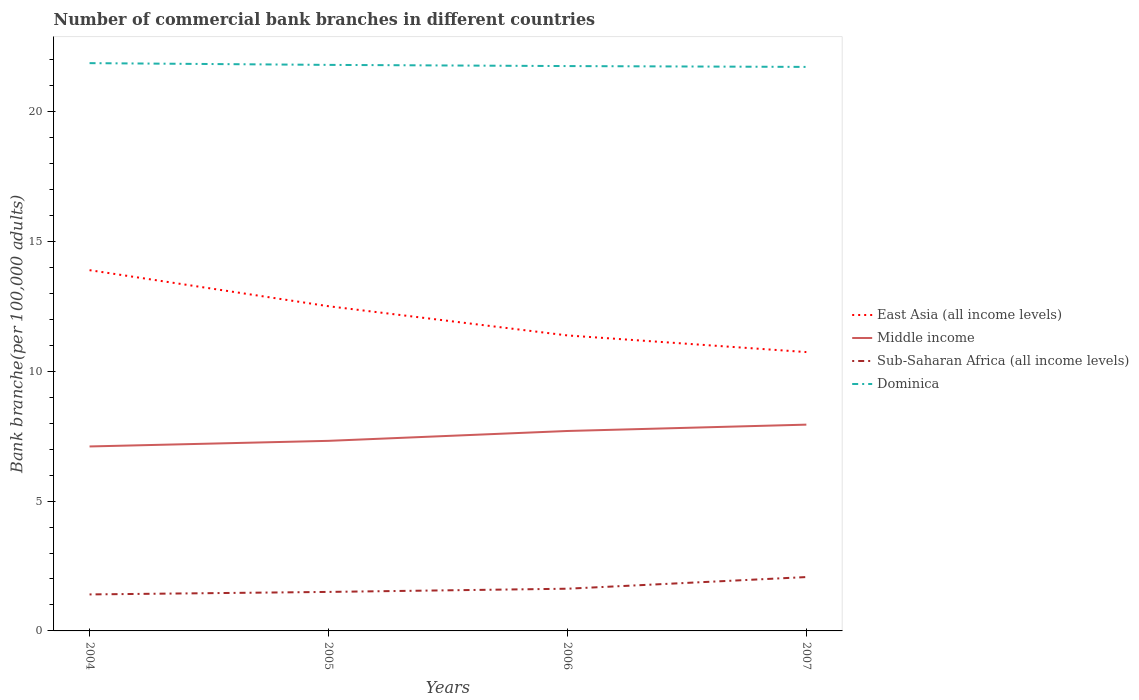How many different coloured lines are there?
Ensure brevity in your answer.  4. Does the line corresponding to Sub-Saharan Africa (all income levels) intersect with the line corresponding to Middle income?
Your answer should be very brief. No. Across all years, what is the maximum number of commercial bank branches in Dominica?
Your answer should be compact. 21.72. What is the total number of commercial bank branches in Sub-Saharan Africa (all income levels) in the graph?
Give a very brief answer. -0.1. What is the difference between the highest and the second highest number of commercial bank branches in Dominica?
Your answer should be very brief. 0.15. How many lines are there?
Your response must be concise. 4. How many years are there in the graph?
Make the answer very short. 4. What is the difference between two consecutive major ticks on the Y-axis?
Make the answer very short. 5. Does the graph contain any zero values?
Offer a very short reply. No. Where does the legend appear in the graph?
Your response must be concise. Center right. How are the legend labels stacked?
Offer a terse response. Vertical. What is the title of the graph?
Make the answer very short. Number of commercial bank branches in different countries. What is the label or title of the Y-axis?
Offer a very short reply. Bank branche(per 100,0 adults). What is the Bank branche(per 100,000 adults) in East Asia (all income levels) in 2004?
Ensure brevity in your answer.  13.89. What is the Bank branche(per 100,000 adults) in Middle income in 2004?
Provide a short and direct response. 7.1. What is the Bank branche(per 100,000 adults) in Sub-Saharan Africa (all income levels) in 2004?
Your response must be concise. 1.41. What is the Bank branche(per 100,000 adults) in Dominica in 2004?
Provide a succinct answer. 21.86. What is the Bank branche(per 100,000 adults) of East Asia (all income levels) in 2005?
Your answer should be very brief. 12.5. What is the Bank branche(per 100,000 adults) of Middle income in 2005?
Your response must be concise. 7.32. What is the Bank branche(per 100,000 adults) of Sub-Saharan Africa (all income levels) in 2005?
Provide a short and direct response. 1.5. What is the Bank branche(per 100,000 adults) in Dominica in 2005?
Your answer should be compact. 21.8. What is the Bank branche(per 100,000 adults) in East Asia (all income levels) in 2006?
Keep it short and to the point. 11.38. What is the Bank branche(per 100,000 adults) in Middle income in 2006?
Your response must be concise. 7.7. What is the Bank branche(per 100,000 adults) of Sub-Saharan Africa (all income levels) in 2006?
Offer a terse response. 1.63. What is the Bank branche(per 100,000 adults) of Dominica in 2006?
Your response must be concise. 21.75. What is the Bank branche(per 100,000 adults) in East Asia (all income levels) in 2007?
Your answer should be compact. 10.74. What is the Bank branche(per 100,000 adults) of Middle income in 2007?
Provide a short and direct response. 7.94. What is the Bank branche(per 100,000 adults) in Sub-Saharan Africa (all income levels) in 2007?
Your response must be concise. 2.07. What is the Bank branche(per 100,000 adults) of Dominica in 2007?
Give a very brief answer. 21.72. Across all years, what is the maximum Bank branche(per 100,000 adults) of East Asia (all income levels)?
Keep it short and to the point. 13.89. Across all years, what is the maximum Bank branche(per 100,000 adults) in Middle income?
Provide a succinct answer. 7.94. Across all years, what is the maximum Bank branche(per 100,000 adults) of Sub-Saharan Africa (all income levels)?
Keep it short and to the point. 2.07. Across all years, what is the maximum Bank branche(per 100,000 adults) in Dominica?
Your answer should be compact. 21.86. Across all years, what is the minimum Bank branche(per 100,000 adults) of East Asia (all income levels)?
Your answer should be very brief. 10.74. Across all years, what is the minimum Bank branche(per 100,000 adults) in Middle income?
Provide a short and direct response. 7.1. Across all years, what is the minimum Bank branche(per 100,000 adults) of Sub-Saharan Africa (all income levels)?
Offer a very short reply. 1.41. Across all years, what is the minimum Bank branche(per 100,000 adults) in Dominica?
Keep it short and to the point. 21.72. What is the total Bank branche(per 100,000 adults) in East Asia (all income levels) in the graph?
Make the answer very short. 48.51. What is the total Bank branche(per 100,000 adults) in Middle income in the graph?
Offer a terse response. 30.06. What is the total Bank branche(per 100,000 adults) in Sub-Saharan Africa (all income levels) in the graph?
Your response must be concise. 6.61. What is the total Bank branche(per 100,000 adults) of Dominica in the graph?
Provide a succinct answer. 87.12. What is the difference between the Bank branche(per 100,000 adults) of East Asia (all income levels) in 2004 and that in 2005?
Your response must be concise. 1.39. What is the difference between the Bank branche(per 100,000 adults) in Middle income in 2004 and that in 2005?
Your answer should be very brief. -0.22. What is the difference between the Bank branche(per 100,000 adults) in Sub-Saharan Africa (all income levels) in 2004 and that in 2005?
Offer a terse response. -0.1. What is the difference between the Bank branche(per 100,000 adults) in Dominica in 2004 and that in 2005?
Provide a succinct answer. 0.07. What is the difference between the Bank branche(per 100,000 adults) in East Asia (all income levels) in 2004 and that in 2006?
Your answer should be compact. 2.51. What is the difference between the Bank branche(per 100,000 adults) of Middle income in 2004 and that in 2006?
Keep it short and to the point. -0.6. What is the difference between the Bank branche(per 100,000 adults) of Sub-Saharan Africa (all income levels) in 2004 and that in 2006?
Your response must be concise. -0.22. What is the difference between the Bank branche(per 100,000 adults) in Dominica in 2004 and that in 2006?
Your answer should be compact. 0.11. What is the difference between the Bank branche(per 100,000 adults) of East Asia (all income levels) in 2004 and that in 2007?
Offer a terse response. 3.15. What is the difference between the Bank branche(per 100,000 adults) in Middle income in 2004 and that in 2007?
Offer a very short reply. -0.84. What is the difference between the Bank branche(per 100,000 adults) in Sub-Saharan Africa (all income levels) in 2004 and that in 2007?
Offer a terse response. -0.67. What is the difference between the Bank branche(per 100,000 adults) in Dominica in 2004 and that in 2007?
Ensure brevity in your answer.  0.15. What is the difference between the Bank branche(per 100,000 adults) in East Asia (all income levels) in 2005 and that in 2006?
Your answer should be very brief. 1.12. What is the difference between the Bank branche(per 100,000 adults) of Middle income in 2005 and that in 2006?
Your answer should be very brief. -0.38. What is the difference between the Bank branche(per 100,000 adults) of Sub-Saharan Africa (all income levels) in 2005 and that in 2006?
Your answer should be very brief. -0.12. What is the difference between the Bank branche(per 100,000 adults) in Dominica in 2005 and that in 2006?
Your answer should be very brief. 0.05. What is the difference between the Bank branche(per 100,000 adults) in East Asia (all income levels) in 2005 and that in 2007?
Provide a succinct answer. 1.77. What is the difference between the Bank branche(per 100,000 adults) of Middle income in 2005 and that in 2007?
Offer a very short reply. -0.62. What is the difference between the Bank branche(per 100,000 adults) of Sub-Saharan Africa (all income levels) in 2005 and that in 2007?
Make the answer very short. -0.57. What is the difference between the Bank branche(per 100,000 adults) in Dominica in 2005 and that in 2007?
Offer a very short reply. 0.08. What is the difference between the Bank branche(per 100,000 adults) of East Asia (all income levels) in 2006 and that in 2007?
Your answer should be compact. 0.64. What is the difference between the Bank branche(per 100,000 adults) of Middle income in 2006 and that in 2007?
Make the answer very short. -0.24. What is the difference between the Bank branche(per 100,000 adults) in Sub-Saharan Africa (all income levels) in 2006 and that in 2007?
Provide a short and direct response. -0.45. What is the difference between the Bank branche(per 100,000 adults) of Dominica in 2006 and that in 2007?
Provide a short and direct response. 0.03. What is the difference between the Bank branche(per 100,000 adults) in East Asia (all income levels) in 2004 and the Bank branche(per 100,000 adults) in Middle income in 2005?
Provide a succinct answer. 6.57. What is the difference between the Bank branche(per 100,000 adults) of East Asia (all income levels) in 2004 and the Bank branche(per 100,000 adults) of Sub-Saharan Africa (all income levels) in 2005?
Keep it short and to the point. 12.39. What is the difference between the Bank branche(per 100,000 adults) in East Asia (all income levels) in 2004 and the Bank branche(per 100,000 adults) in Dominica in 2005?
Keep it short and to the point. -7.9. What is the difference between the Bank branche(per 100,000 adults) of Middle income in 2004 and the Bank branche(per 100,000 adults) of Sub-Saharan Africa (all income levels) in 2005?
Your answer should be compact. 5.6. What is the difference between the Bank branche(per 100,000 adults) of Middle income in 2004 and the Bank branche(per 100,000 adults) of Dominica in 2005?
Provide a short and direct response. -14.69. What is the difference between the Bank branche(per 100,000 adults) in Sub-Saharan Africa (all income levels) in 2004 and the Bank branche(per 100,000 adults) in Dominica in 2005?
Your answer should be very brief. -20.39. What is the difference between the Bank branche(per 100,000 adults) in East Asia (all income levels) in 2004 and the Bank branche(per 100,000 adults) in Middle income in 2006?
Provide a short and direct response. 6.19. What is the difference between the Bank branche(per 100,000 adults) of East Asia (all income levels) in 2004 and the Bank branche(per 100,000 adults) of Sub-Saharan Africa (all income levels) in 2006?
Your response must be concise. 12.27. What is the difference between the Bank branche(per 100,000 adults) in East Asia (all income levels) in 2004 and the Bank branche(per 100,000 adults) in Dominica in 2006?
Ensure brevity in your answer.  -7.86. What is the difference between the Bank branche(per 100,000 adults) in Middle income in 2004 and the Bank branche(per 100,000 adults) in Sub-Saharan Africa (all income levels) in 2006?
Keep it short and to the point. 5.48. What is the difference between the Bank branche(per 100,000 adults) of Middle income in 2004 and the Bank branche(per 100,000 adults) of Dominica in 2006?
Your answer should be very brief. -14.65. What is the difference between the Bank branche(per 100,000 adults) in Sub-Saharan Africa (all income levels) in 2004 and the Bank branche(per 100,000 adults) in Dominica in 2006?
Keep it short and to the point. -20.34. What is the difference between the Bank branche(per 100,000 adults) in East Asia (all income levels) in 2004 and the Bank branche(per 100,000 adults) in Middle income in 2007?
Ensure brevity in your answer.  5.95. What is the difference between the Bank branche(per 100,000 adults) of East Asia (all income levels) in 2004 and the Bank branche(per 100,000 adults) of Sub-Saharan Africa (all income levels) in 2007?
Your answer should be compact. 11.82. What is the difference between the Bank branche(per 100,000 adults) of East Asia (all income levels) in 2004 and the Bank branche(per 100,000 adults) of Dominica in 2007?
Make the answer very short. -7.83. What is the difference between the Bank branche(per 100,000 adults) in Middle income in 2004 and the Bank branche(per 100,000 adults) in Sub-Saharan Africa (all income levels) in 2007?
Ensure brevity in your answer.  5.03. What is the difference between the Bank branche(per 100,000 adults) in Middle income in 2004 and the Bank branche(per 100,000 adults) in Dominica in 2007?
Give a very brief answer. -14.61. What is the difference between the Bank branche(per 100,000 adults) of Sub-Saharan Africa (all income levels) in 2004 and the Bank branche(per 100,000 adults) of Dominica in 2007?
Offer a terse response. -20.31. What is the difference between the Bank branche(per 100,000 adults) of East Asia (all income levels) in 2005 and the Bank branche(per 100,000 adults) of Middle income in 2006?
Give a very brief answer. 4.8. What is the difference between the Bank branche(per 100,000 adults) in East Asia (all income levels) in 2005 and the Bank branche(per 100,000 adults) in Sub-Saharan Africa (all income levels) in 2006?
Make the answer very short. 10.88. What is the difference between the Bank branche(per 100,000 adults) in East Asia (all income levels) in 2005 and the Bank branche(per 100,000 adults) in Dominica in 2006?
Your answer should be compact. -9.25. What is the difference between the Bank branche(per 100,000 adults) in Middle income in 2005 and the Bank branche(per 100,000 adults) in Sub-Saharan Africa (all income levels) in 2006?
Your response must be concise. 5.69. What is the difference between the Bank branche(per 100,000 adults) in Middle income in 2005 and the Bank branche(per 100,000 adults) in Dominica in 2006?
Your answer should be very brief. -14.43. What is the difference between the Bank branche(per 100,000 adults) in Sub-Saharan Africa (all income levels) in 2005 and the Bank branche(per 100,000 adults) in Dominica in 2006?
Provide a succinct answer. -20.25. What is the difference between the Bank branche(per 100,000 adults) in East Asia (all income levels) in 2005 and the Bank branche(per 100,000 adults) in Middle income in 2007?
Your response must be concise. 4.56. What is the difference between the Bank branche(per 100,000 adults) of East Asia (all income levels) in 2005 and the Bank branche(per 100,000 adults) of Sub-Saharan Africa (all income levels) in 2007?
Offer a very short reply. 10.43. What is the difference between the Bank branche(per 100,000 adults) in East Asia (all income levels) in 2005 and the Bank branche(per 100,000 adults) in Dominica in 2007?
Your answer should be compact. -9.21. What is the difference between the Bank branche(per 100,000 adults) of Middle income in 2005 and the Bank branche(per 100,000 adults) of Sub-Saharan Africa (all income levels) in 2007?
Keep it short and to the point. 5.24. What is the difference between the Bank branche(per 100,000 adults) of Middle income in 2005 and the Bank branche(per 100,000 adults) of Dominica in 2007?
Provide a succinct answer. -14.4. What is the difference between the Bank branche(per 100,000 adults) in Sub-Saharan Africa (all income levels) in 2005 and the Bank branche(per 100,000 adults) in Dominica in 2007?
Offer a terse response. -20.22. What is the difference between the Bank branche(per 100,000 adults) in East Asia (all income levels) in 2006 and the Bank branche(per 100,000 adults) in Middle income in 2007?
Offer a very short reply. 3.43. What is the difference between the Bank branche(per 100,000 adults) of East Asia (all income levels) in 2006 and the Bank branche(per 100,000 adults) of Sub-Saharan Africa (all income levels) in 2007?
Offer a very short reply. 9.3. What is the difference between the Bank branche(per 100,000 adults) in East Asia (all income levels) in 2006 and the Bank branche(per 100,000 adults) in Dominica in 2007?
Keep it short and to the point. -10.34. What is the difference between the Bank branche(per 100,000 adults) in Middle income in 2006 and the Bank branche(per 100,000 adults) in Sub-Saharan Africa (all income levels) in 2007?
Provide a short and direct response. 5.62. What is the difference between the Bank branche(per 100,000 adults) in Middle income in 2006 and the Bank branche(per 100,000 adults) in Dominica in 2007?
Your answer should be compact. -14.02. What is the difference between the Bank branche(per 100,000 adults) in Sub-Saharan Africa (all income levels) in 2006 and the Bank branche(per 100,000 adults) in Dominica in 2007?
Keep it short and to the point. -20.09. What is the average Bank branche(per 100,000 adults) of East Asia (all income levels) per year?
Your response must be concise. 12.13. What is the average Bank branche(per 100,000 adults) of Middle income per year?
Provide a succinct answer. 7.52. What is the average Bank branche(per 100,000 adults) of Sub-Saharan Africa (all income levels) per year?
Your answer should be very brief. 1.65. What is the average Bank branche(per 100,000 adults) in Dominica per year?
Offer a terse response. 21.78. In the year 2004, what is the difference between the Bank branche(per 100,000 adults) of East Asia (all income levels) and Bank branche(per 100,000 adults) of Middle income?
Provide a short and direct response. 6.79. In the year 2004, what is the difference between the Bank branche(per 100,000 adults) of East Asia (all income levels) and Bank branche(per 100,000 adults) of Sub-Saharan Africa (all income levels)?
Your response must be concise. 12.49. In the year 2004, what is the difference between the Bank branche(per 100,000 adults) of East Asia (all income levels) and Bank branche(per 100,000 adults) of Dominica?
Provide a succinct answer. -7.97. In the year 2004, what is the difference between the Bank branche(per 100,000 adults) of Middle income and Bank branche(per 100,000 adults) of Sub-Saharan Africa (all income levels)?
Provide a short and direct response. 5.7. In the year 2004, what is the difference between the Bank branche(per 100,000 adults) in Middle income and Bank branche(per 100,000 adults) in Dominica?
Your answer should be compact. -14.76. In the year 2004, what is the difference between the Bank branche(per 100,000 adults) of Sub-Saharan Africa (all income levels) and Bank branche(per 100,000 adults) of Dominica?
Keep it short and to the point. -20.46. In the year 2005, what is the difference between the Bank branche(per 100,000 adults) in East Asia (all income levels) and Bank branche(per 100,000 adults) in Middle income?
Your answer should be compact. 5.18. In the year 2005, what is the difference between the Bank branche(per 100,000 adults) of East Asia (all income levels) and Bank branche(per 100,000 adults) of Sub-Saharan Africa (all income levels)?
Ensure brevity in your answer.  11. In the year 2005, what is the difference between the Bank branche(per 100,000 adults) in East Asia (all income levels) and Bank branche(per 100,000 adults) in Dominica?
Offer a terse response. -9.29. In the year 2005, what is the difference between the Bank branche(per 100,000 adults) in Middle income and Bank branche(per 100,000 adults) in Sub-Saharan Africa (all income levels)?
Make the answer very short. 5.82. In the year 2005, what is the difference between the Bank branche(per 100,000 adults) in Middle income and Bank branche(per 100,000 adults) in Dominica?
Provide a succinct answer. -14.48. In the year 2005, what is the difference between the Bank branche(per 100,000 adults) in Sub-Saharan Africa (all income levels) and Bank branche(per 100,000 adults) in Dominica?
Ensure brevity in your answer.  -20.29. In the year 2006, what is the difference between the Bank branche(per 100,000 adults) of East Asia (all income levels) and Bank branche(per 100,000 adults) of Middle income?
Your answer should be compact. 3.68. In the year 2006, what is the difference between the Bank branche(per 100,000 adults) of East Asia (all income levels) and Bank branche(per 100,000 adults) of Sub-Saharan Africa (all income levels)?
Make the answer very short. 9.75. In the year 2006, what is the difference between the Bank branche(per 100,000 adults) in East Asia (all income levels) and Bank branche(per 100,000 adults) in Dominica?
Your response must be concise. -10.37. In the year 2006, what is the difference between the Bank branche(per 100,000 adults) of Middle income and Bank branche(per 100,000 adults) of Sub-Saharan Africa (all income levels)?
Your response must be concise. 6.07. In the year 2006, what is the difference between the Bank branche(per 100,000 adults) in Middle income and Bank branche(per 100,000 adults) in Dominica?
Your answer should be compact. -14.05. In the year 2006, what is the difference between the Bank branche(per 100,000 adults) of Sub-Saharan Africa (all income levels) and Bank branche(per 100,000 adults) of Dominica?
Your answer should be compact. -20.12. In the year 2007, what is the difference between the Bank branche(per 100,000 adults) in East Asia (all income levels) and Bank branche(per 100,000 adults) in Middle income?
Offer a terse response. 2.79. In the year 2007, what is the difference between the Bank branche(per 100,000 adults) of East Asia (all income levels) and Bank branche(per 100,000 adults) of Sub-Saharan Africa (all income levels)?
Give a very brief answer. 8.66. In the year 2007, what is the difference between the Bank branche(per 100,000 adults) of East Asia (all income levels) and Bank branche(per 100,000 adults) of Dominica?
Offer a terse response. -10.98. In the year 2007, what is the difference between the Bank branche(per 100,000 adults) in Middle income and Bank branche(per 100,000 adults) in Sub-Saharan Africa (all income levels)?
Offer a very short reply. 5.87. In the year 2007, what is the difference between the Bank branche(per 100,000 adults) in Middle income and Bank branche(per 100,000 adults) in Dominica?
Offer a terse response. -13.77. In the year 2007, what is the difference between the Bank branche(per 100,000 adults) of Sub-Saharan Africa (all income levels) and Bank branche(per 100,000 adults) of Dominica?
Keep it short and to the point. -19.64. What is the ratio of the Bank branche(per 100,000 adults) in East Asia (all income levels) in 2004 to that in 2005?
Your response must be concise. 1.11. What is the ratio of the Bank branche(per 100,000 adults) of Middle income in 2004 to that in 2005?
Provide a short and direct response. 0.97. What is the ratio of the Bank branche(per 100,000 adults) of Sub-Saharan Africa (all income levels) in 2004 to that in 2005?
Keep it short and to the point. 0.94. What is the ratio of the Bank branche(per 100,000 adults) of Dominica in 2004 to that in 2005?
Your response must be concise. 1. What is the ratio of the Bank branche(per 100,000 adults) of East Asia (all income levels) in 2004 to that in 2006?
Your answer should be compact. 1.22. What is the ratio of the Bank branche(per 100,000 adults) in Middle income in 2004 to that in 2006?
Your answer should be very brief. 0.92. What is the ratio of the Bank branche(per 100,000 adults) of Sub-Saharan Africa (all income levels) in 2004 to that in 2006?
Provide a succinct answer. 0.86. What is the ratio of the Bank branche(per 100,000 adults) of East Asia (all income levels) in 2004 to that in 2007?
Give a very brief answer. 1.29. What is the ratio of the Bank branche(per 100,000 adults) in Middle income in 2004 to that in 2007?
Provide a succinct answer. 0.89. What is the ratio of the Bank branche(per 100,000 adults) in Sub-Saharan Africa (all income levels) in 2004 to that in 2007?
Give a very brief answer. 0.68. What is the ratio of the Bank branche(per 100,000 adults) in East Asia (all income levels) in 2005 to that in 2006?
Your response must be concise. 1.1. What is the ratio of the Bank branche(per 100,000 adults) in Middle income in 2005 to that in 2006?
Your response must be concise. 0.95. What is the ratio of the Bank branche(per 100,000 adults) of Sub-Saharan Africa (all income levels) in 2005 to that in 2006?
Give a very brief answer. 0.92. What is the ratio of the Bank branche(per 100,000 adults) in Dominica in 2005 to that in 2006?
Your response must be concise. 1. What is the ratio of the Bank branche(per 100,000 adults) of East Asia (all income levels) in 2005 to that in 2007?
Offer a terse response. 1.16. What is the ratio of the Bank branche(per 100,000 adults) of Middle income in 2005 to that in 2007?
Make the answer very short. 0.92. What is the ratio of the Bank branche(per 100,000 adults) of Sub-Saharan Africa (all income levels) in 2005 to that in 2007?
Keep it short and to the point. 0.72. What is the ratio of the Bank branche(per 100,000 adults) of East Asia (all income levels) in 2006 to that in 2007?
Give a very brief answer. 1.06. What is the ratio of the Bank branche(per 100,000 adults) of Middle income in 2006 to that in 2007?
Provide a succinct answer. 0.97. What is the ratio of the Bank branche(per 100,000 adults) in Sub-Saharan Africa (all income levels) in 2006 to that in 2007?
Your answer should be very brief. 0.78. What is the difference between the highest and the second highest Bank branche(per 100,000 adults) in East Asia (all income levels)?
Make the answer very short. 1.39. What is the difference between the highest and the second highest Bank branche(per 100,000 adults) in Middle income?
Your response must be concise. 0.24. What is the difference between the highest and the second highest Bank branche(per 100,000 adults) of Sub-Saharan Africa (all income levels)?
Your answer should be compact. 0.45. What is the difference between the highest and the second highest Bank branche(per 100,000 adults) in Dominica?
Give a very brief answer. 0.07. What is the difference between the highest and the lowest Bank branche(per 100,000 adults) in East Asia (all income levels)?
Make the answer very short. 3.15. What is the difference between the highest and the lowest Bank branche(per 100,000 adults) of Middle income?
Offer a very short reply. 0.84. What is the difference between the highest and the lowest Bank branche(per 100,000 adults) of Sub-Saharan Africa (all income levels)?
Your answer should be compact. 0.67. What is the difference between the highest and the lowest Bank branche(per 100,000 adults) in Dominica?
Give a very brief answer. 0.15. 